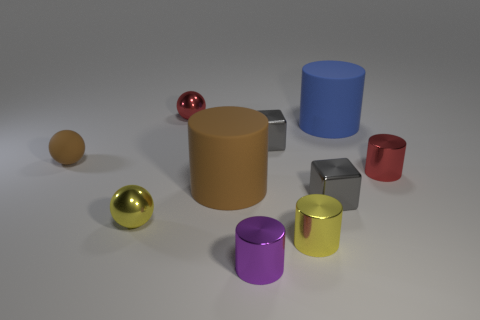Does the ball in front of the brown sphere have the same size as the red metal cylinder?
Provide a succinct answer. Yes. Is there a big blue cylinder made of the same material as the brown sphere?
Make the answer very short. Yes. How many things are either large matte things that are in front of the blue cylinder or small yellow metallic cylinders?
Ensure brevity in your answer.  2. Are there any rubber balls?
Your answer should be very brief. Yes. There is a rubber object that is behind the small red metallic cylinder and to the left of the large blue matte cylinder; what shape is it?
Give a very brief answer. Sphere. There is a yellow shiny object on the right side of the small red metal ball; how big is it?
Make the answer very short. Small. There is a tiny metal cylinder that is right of the blue object; is its color the same as the small rubber thing?
Your answer should be compact. No. What number of large blue objects are the same shape as the big brown matte thing?
Ensure brevity in your answer.  1. What number of objects are tiny red objects that are right of the blue thing or shiny objects to the right of the purple cylinder?
Provide a succinct answer. 4. How many yellow objects are small spheres or big blocks?
Offer a terse response. 1. 